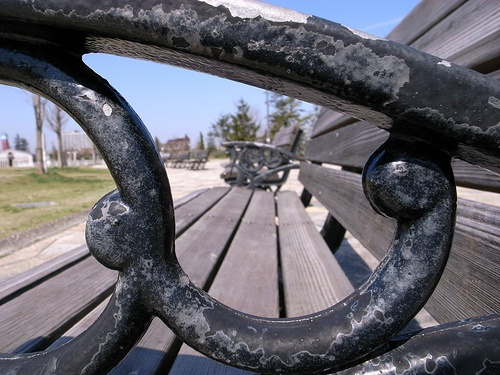Describe the objects in this image and their specific colors. I can see a bench in black, gray, and darkgray tones in this image. 